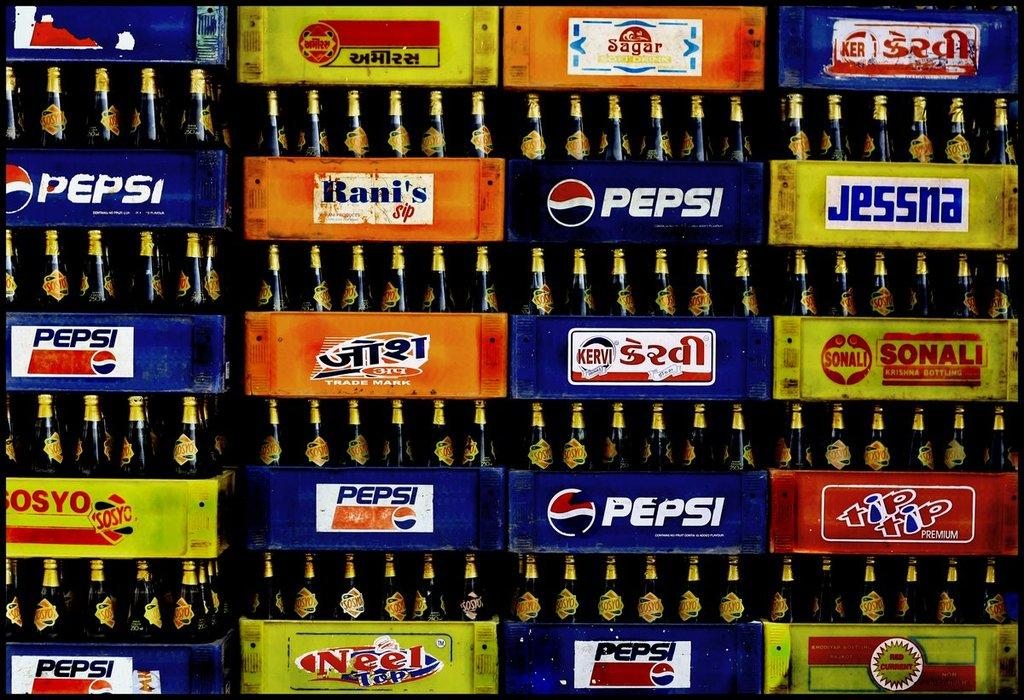<image>
Render a clear and concise summary of the photo. Containers of Pepsi can be seen among other drinks. 